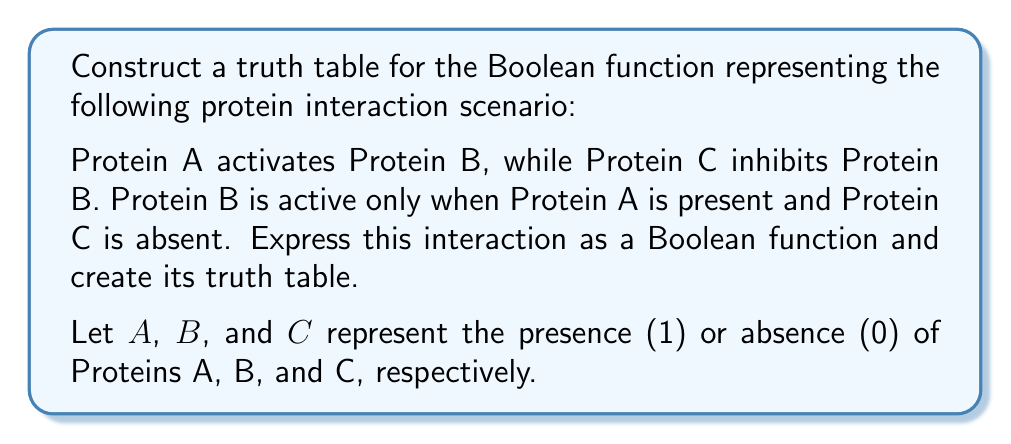What is the answer to this math problem? To solve this problem, we'll follow these steps:

1. Express the protein interaction as a Boolean function.
2. Identify the input variables and possible combinations.
3. Evaluate the function for each input combination.
4. Construct the truth table.

Step 1: Express the protein interaction as a Boolean function

The Boolean function representing this interaction can be written as:

$$ B = A \wedge \neg C $$

Where $\wedge$ represents AND, and $\neg$ represents NOT.

Step 2: Identify input variables and possible combinations

We have two input variables: $A$ and $C$. Each can be either 0 or 1, giving us $2^2 = 4$ possible input combinations.

Step 3: Evaluate the function for each input combination

For each combination of $A$ and $C$, we'll evaluate $B$:

1. $A = 0$, $C = 0$: $B = 0 \wedge \neg 0 = 0 \wedge 1 = 0$
2. $A = 0$, $C = 1$: $B = 0 \wedge \neg 1 = 0 \wedge 0 = 0$
3. $A = 1$, $C = 0$: $B = 1 \wedge \neg 0 = 1 \wedge 1 = 1$
4. $A = 1$, $C = 1$: $B = 1 \wedge \neg 1 = 1 \wedge 0 = 0$

Step 4: Construct the truth table

Now we can construct the truth table:

| $A$ | $C$ | $B$ |
|-----|-----|-----|
|  0  |  0  |  0  |
|  0  |  1  |  0  |
|  1  |  0  |  1  |
|  1  |  1  |  0  |

This truth table accurately represents the given protein interaction scenario, where Protein B is only active (1) when Protein A is present (1) and Protein C is absent (0).
Answer: The truth table for the Boolean function $B = A \wedge \neg C$ is:

| $A$ | $C$ | $B$ |
|-----|-----|-----|
|  0  |  0  |  0  |
|  0  |  1  |  0  |
|  1  |  0  |  1  |
|  1  |  1  |  0  | 